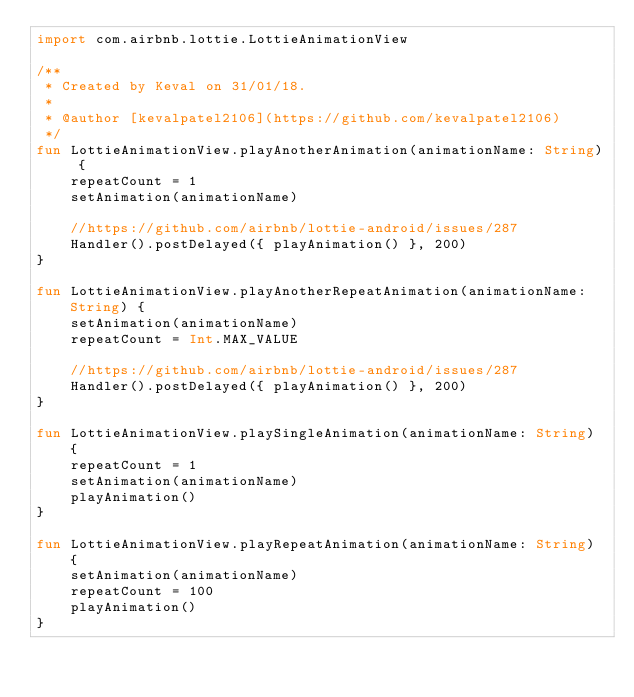<code> <loc_0><loc_0><loc_500><loc_500><_Kotlin_>import com.airbnb.lottie.LottieAnimationView

/**
 * Created by Keval on 31/01/18.
 *
 * @author [kevalpatel2106](https://github.com/kevalpatel2106)
 */
fun LottieAnimationView.playAnotherAnimation(animationName: String) {
    repeatCount = 1
    setAnimation(animationName)

    //https://github.com/airbnb/lottie-android/issues/287
    Handler().postDelayed({ playAnimation() }, 200)
}

fun LottieAnimationView.playAnotherRepeatAnimation(animationName: String) {
    setAnimation(animationName)
    repeatCount = Int.MAX_VALUE

    //https://github.com/airbnb/lottie-android/issues/287
    Handler().postDelayed({ playAnimation() }, 200)
}

fun LottieAnimationView.playSingleAnimation(animationName: String) {
    repeatCount = 1
    setAnimation(animationName)
    playAnimation()
}

fun LottieAnimationView.playRepeatAnimation(animationName: String) {
    setAnimation(animationName)
    repeatCount = 100
    playAnimation()
}
</code> 